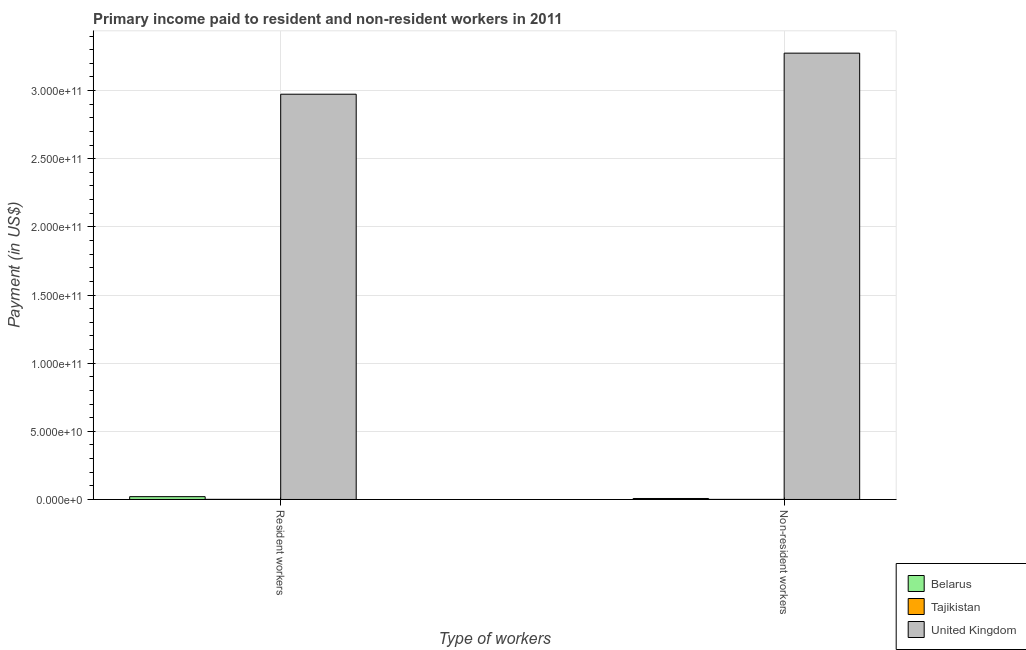How many different coloured bars are there?
Provide a short and direct response. 3. Are the number of bars per tick equal to the number of legend labels?
Your answer should be very brief. Yes. How many bars are there on the 2nd tick from the right?
Keep it short and to the point. 3. What is the label of the 2nd group of bars from the left?
Keep it short and to the point. Non-resident workers. What is the payment made to non-resident workers in Tajikistan?
Give a very brief answer. 4.01e+07. Across all countries, what is the maximum payment made to resident workers?
Your answer should be compact. 2.97e+11. Across all countries, what is the minimum payment made to non-resident workers?
Offer a terse response. 4.01e+07. In which country was the payment made to non-resident workers minimum?
Offer a terse response. Tajikistan. What is the total payment made to resident workers in the graph?
Make the answer very short. 2.99e+11. What is the difference between the payment made to non-resident workers in Tajikistan and that in Belarus?
Provide a succinct answer. -6.65e+08. What is the difference between the payment made to non-resident workers in Tajikistan and the payment made to resident workers in United Kingdom?
Your answer should be very brief. -2.97e+11. What is the average payment made to resident workers per country?
Keep it short and to the point. 9.98e+1. What is the difference between the payment made to non-resident workers and payment made to resident workers in Belarus?
Your answer should be very brief. -1.36e+09. What is the ratio of the payment made to non-resident workers in Tajikistan to that in United Kingdom?
Make the answer very short. 0. Is the payment made to resident workers in Tajikistan less than that in Belarus?
Provide a succinct answer. Yes. In how many countries, is the payment made to resident workers greater than the average payment made to resident workers taken over all countries?
Your answer should be compact. 1. What does the 1st bar from the right in Resident workers represents?
Give a very brief answer. United Kingdom. How many bars are there?
Provide a succinct answer. 6. Are all the bars in the graph horizontal?
Give a very brief answer. No. What is the difference between two consecutive major ticks on the Y-axis?
Your answer should be compact. 5.00e+1. Are the values on the major ticks of Y-axis written in scientific E-notation?
Give a very brief answer. Yes. Does the graph contain any zero values?
Make the answer very short. No. Does the graph contain grids?
Keep it short and to the point. Yes. Where does the legend appear in the graph?
Offer a terse response. Bottom right. How many legend labels are there?
Your response must be concise. 3. How are the legend labels stacked?
Offer a very short reply. Vertical. What is the title of the graph?
Your answer should be very brief. Primary income paid to resident and non-resident workers in 2011. What is the label or title of the X-axis?
Your response must be concise. Type of workers. What is the label or title of the Y-axis?
Your answer should be compact. Payment (in US$). What is the Payment (in US$) in Belarus in Resident workers?
Give a very brief answer. 2.07e+09. What is the Payment (in US$) of Tajikistan in Resident workers?
Ensure brevity in your answer.  7.97e+07. What is the Payment (in US$) of United Kingdom in Resident workers?
Your answer should be very brief. 2.97e+11. What is the Payment (in US$) of Belarus in Non-resident workers?
Your answer should be very brief. 7.05e+08. What is the Payment (in US$) in Tajikistan in Non-resident workers?
Give a very brief answer. 4.01e+07. What is the Payment (in US$) of United Kingdom in Non-resident workers?
Provide a succinct answer. 3.27e+11. Across all Type of workers, what is the maximum Payment (in US$) in Belarus?
Your response must be concise. 2.07e+09. Across all Type of workers, what is the maximum Payment (in US$) in Tajikistan?
Give a very brief answer. 7.97e+07. Across all Type of workers, what is the maximum Payment (in US$) in United Kingdom?
Offer a terse response. 3.27e+11. Across all Type of workers, what is the minimum Payment (in US$) in Belarus?
Make the answer very short. 7.05e+08. Across all Type of workers, what is the minimum Payment (in US$) in Tajikistan?
Offer a very short reply. 4.01e+07. Across all Type of workers, what is the minimum Payment (in US$) of United Kingdom?
Give a very brief answer. 2.97e+11. What is the total Payment (in US$) in Belarus in the graph?
Your response must be concise. 2.77e+09. What is the total Payment (in US$) of Tajikistan in the graph?
Your response must be concise. 1.20e+08. What is the total Payment (in US$) in United Kingdom in the graph?
Offer a terse response. 6.25e+11. What is the difference between the Payment (in US$) of Belarus in Resident workers and that in Non-resident workers?
Ensure brevity in your answer.  1.36e+09. What is the difference between the Payment (in US$) in Tajikistan in Resident workers and that in Non-resident workers?
Offer a very short reply. 3.96e+07. What is the difference between the Payment (in US$) of United Kingdom in Resident workers and that in Non-resident workers?
Ensure brevity in your answer.  -3.01e+1. What is the difference between the Payment (in US$) of Belarus in Resident workers and the Payment (in US$) of Tajikistan in Non-resident workers?
Your response must be concise. 2.03e+09. What is the difference between the Payment (in US$) in Belarus in Resident workers and the Payment (in US$) in United Kingdom in Non-resident workers?
Your response must be concise. -3.25e+11. What is the difference between the Payment (in US$) in Tajikistan in Resident workers and the Payment (in US$) in United Kingdom in Non-resident workers?
Offer a terse response. -3.27e+11. What is the average Payment (in US$) in Belarus per Type of workers?
Your response must be concise. 1.39e+09. What is the average Payment (in US$) in Tajikistan per Type of workers?
Offer a very short reply. 5.99e+07. What is the average Payment (in US$) of United Kingdom per Type of workers?
Your answer should be compact. 3.12e+11. What is the difference between the Payment (in US$) of Belarus and Payment (in US$) of Tajikistan in Resident workers?
Offer a terse response. 1.99e+09. What is the difference between the Payment (in US$) of Belarus and Payment (in US$) of United Kingdom in Resident workers?
Ensure brevity in your answer.  -2.95e+11. What is the difference between the Payment (in US$) of Tajikistan and Payment (in US$) of United Kingdom in Resident workers?
Provide a succinct answer. -2.97e+11. What is the difference between the Payment (in US$) of Belarus and Payment (in US$) of Tajikistan in Non-resident workers?
Your answer should be compact. 6.65e+08. What is the difference between the Payment (in US$) in Belarus and Payment (in US$) in United Kingdom in Non-resident workers?
Your response must be concise. -3.27e+11. What is the difference between the Payment (in US$) in Tajikistan and Payment (in US$) in United Kingdom in Non-resident workers?
Provide a succinct answer. -3.27e+11. What is the ratio of the Payment (in US$) of Belarus in Resident workers to that in Non-resident workers?
Ensure brevity in your answer.  2.93. What is the ratio of the Payment (in US$) in Tajikistan in Resident workers to that in Non-resident workers?
Provide a succinct answer. 1.99. What is the ratio of the Payment (in US$) in United Kingdom in Resident workers to that in Non-resident workers?
Your response must be concise. 0.91. What is the difference between the highest and the second highest Payment (in US$) of Belarus?
Offer a terse response. 1.36e+09. What is the difference between the highest and the second highest Payment (in US$) of Tajikistan?
Offer a terse response. 3.96e+07. What is the difference between the highest and the second highest Payment (in US$) of United Kingdom?
Provide a short and direct response. 3.01e+1. What is the difference between the highest and the lowest Payment (in US$) in Belarus?
Give a very brief answer. 1.36e+09. What is the difference between the highest and the lowest Payment (in US$) of Tajikistan?
Make the answer very short. 3.96e+07. What is the difference between the highest and the lowest Payment (in US$) in United Kingdom?
Your answer should be very brief. 3.01e+1. 